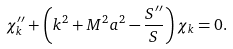Convert formula to latex. <formula><loc_0><loc_0><loc_500><loc_500>\chi _ { k } ^ { \prime \prime } + \left ( k ^ { 2 } + M ^ { 2 } a ^ { 2 } - \frac { S ^ { \prime \prime } } S \right ) \chi _ { k } = 0 .</formula> 